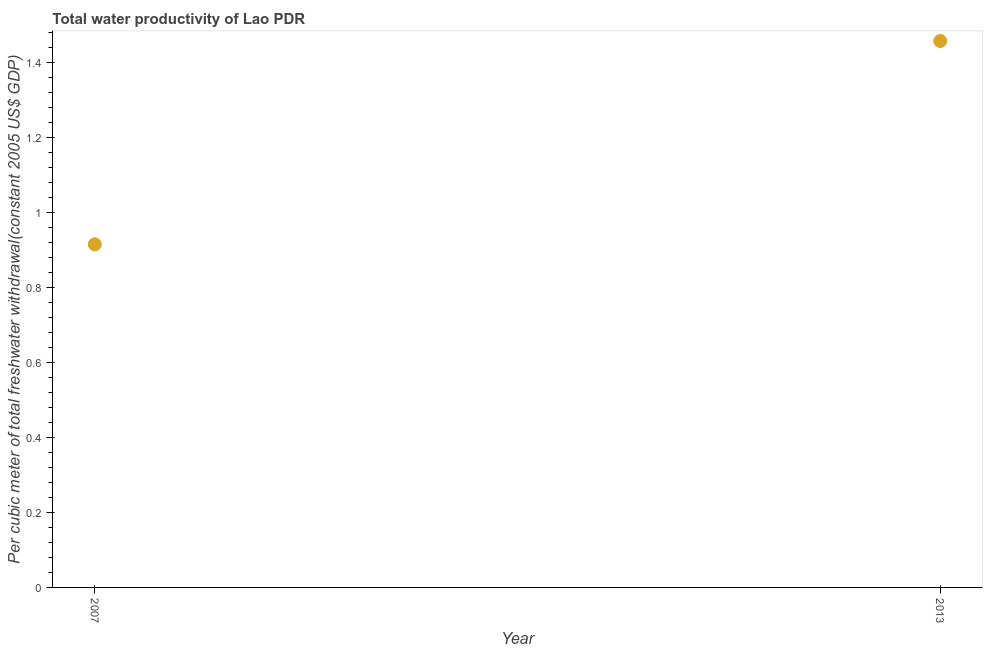What is the total water productivity in 2013?
Give a very brief answer. 1.46. Across all years, what is the maximum total water productivity?
Offer a terse response. 1.46. Across all years, what is the minimum total water productivity?
Make the answer very short. 0.92. In which year was the total water productivity minimum?
Make the answer very short. 2007. What is the sum of the total water productivity?
Make the answer very short. 2.37. What is the difference between the total water productivity in 2007 and 2013?
Make the answer very short. -0.54. What is the average total water productivity per year?
Provide a succinct answer. 1.19. What is the median total water productivity?
Make the answer very short. 1.19. Do a majority of the years between 2013 and 2007 (inclusive) have total water productivity greater than 0.32 US$?
Your answer should be compact. No. What is the ratio of the total water productivity in 2007 to that in 2013?
Provide a short and direct response. 0.63. In how many years, is the total water productivity greater than the average total water productivity taken over all years?
Give a very brief answer. 1. Does the total water productivity monotonically increase over the years?
Keep it short and to the point. Yes. How many dotlines are there?
Make the answer very short. 1. What is the difference between two consecutive major ticks on the Y-axis?
Keep it short and to the point. 0.2. Does the graph contain any zero values?
Offer a very short reply. No. Does the graph contain grids?
Offer a terse response. No. What is the title of the graph?
Your answer should be very brief. Total water productivity of Lao PDR. What is the label or title of the X-axis?
Your answer should be compact. Year. What is the label or title of the Y-axis?
Keep it short and to the point. Per cubic meter of total freshwater withdrawal(constant 2005 US$ GDP). What is the Per cubic meter of total freshwater withdrawal(constant 2005 US$ GDP) in 2007?
Ensure brevity in your answer.  0.92. What is the Per cubic meter of total freshwater withdrawal(constant 2005 US$ GDP) in 2013?
Your answer should be very brief. 1.46. What is the difference between the Per cubic meter of total freshwater withdrawal(constant 2005 US$ GDP) in 2007 and 2013?
Ensure brevity in your answer.  -0.54. What is the ratio of the Per cubic meter of total freshwater withdrawal(constant 2005 US$ GDP) in 2007 to that in 2013?
Your response must be concise. 0.63. 